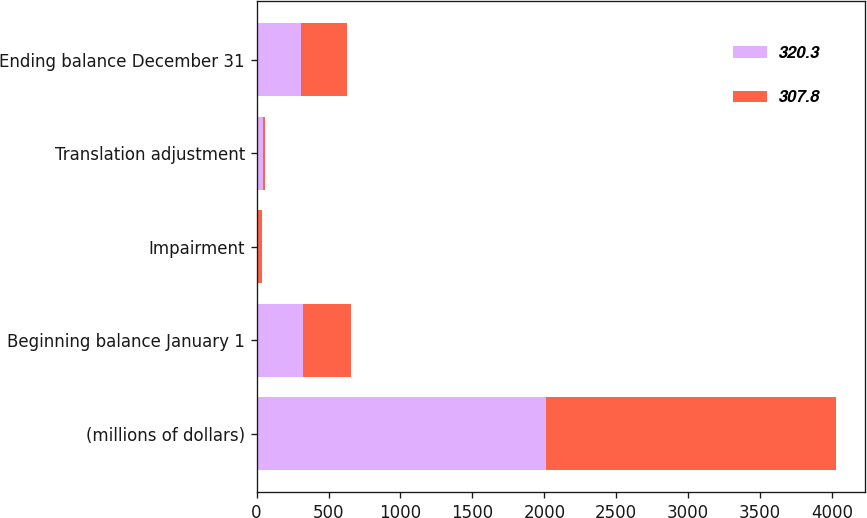Convert chart. <chart><loc_0><loc_0><loc_500><loc_500><stacked_bar_chart><ecel><fcel>(millions of dollars)<fcel>Beginning balance January 1<fcel>Impairment<fcel>Translation adjustment<fcel>Ending balance December 31<nl><fcel>320.3<fcel>2014<fcel>320.3<fcel>10.3<fcel>44.9<fcel>307.8<nl><fcel>307.8<fcel>2013<fcel>335.4<fcel>26.4<fcel>12.4<fcel>320.3<nl></chart> 